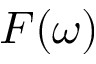<formula> <loc_0><loc_0><loc_500><loc_500>F ( \omega )</formula> 